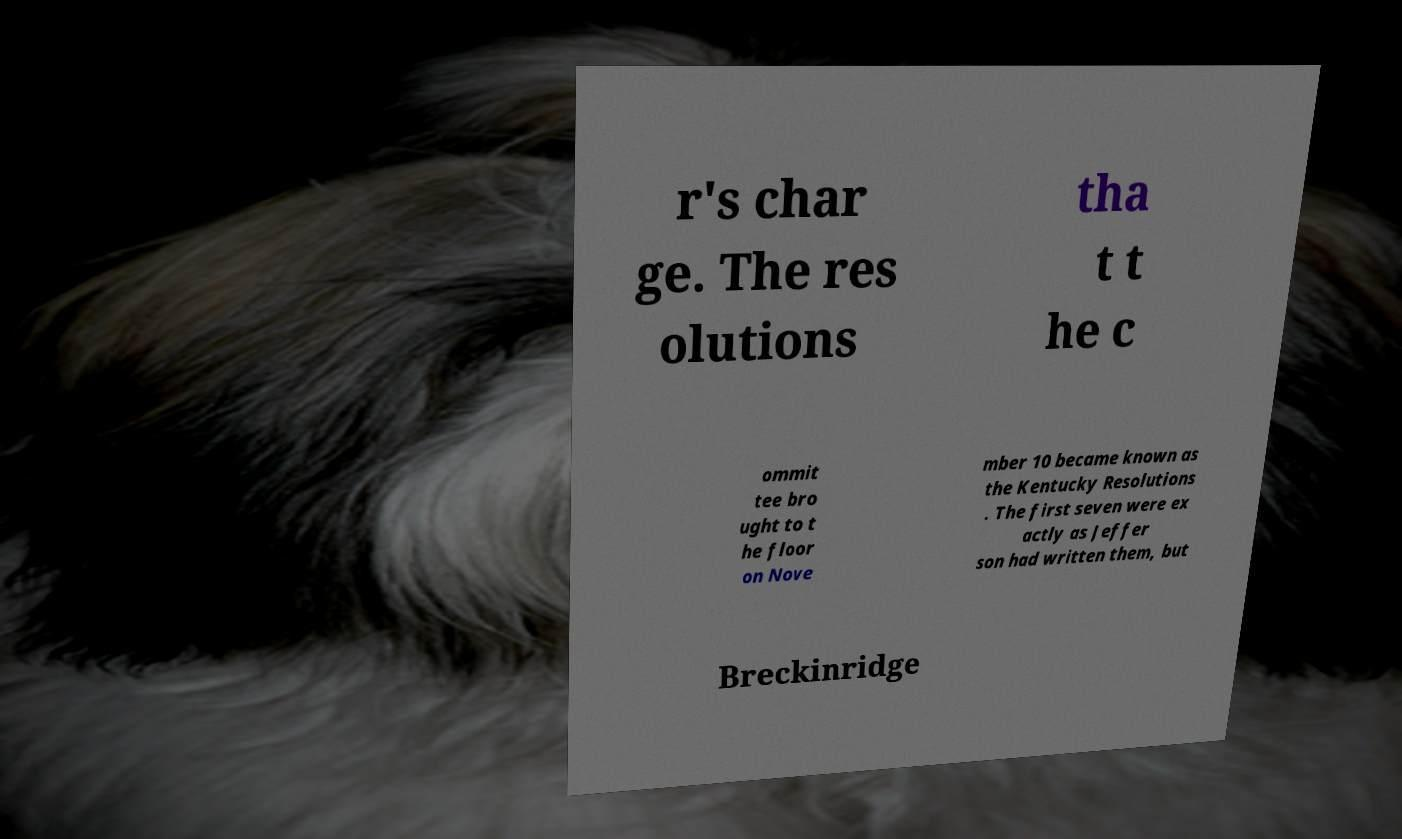What messages or text are displayed in this image? I need them in a readable, typed format. r's char ge. The res olutions tha t t he c ommit tee bro ught to t he floor on Nove mber 10 became known as the Kentucky Resolutions . The first seven were ex actly as Jeffer son had written them, but Breckinridge 